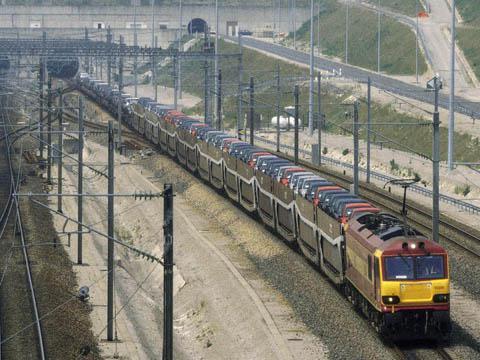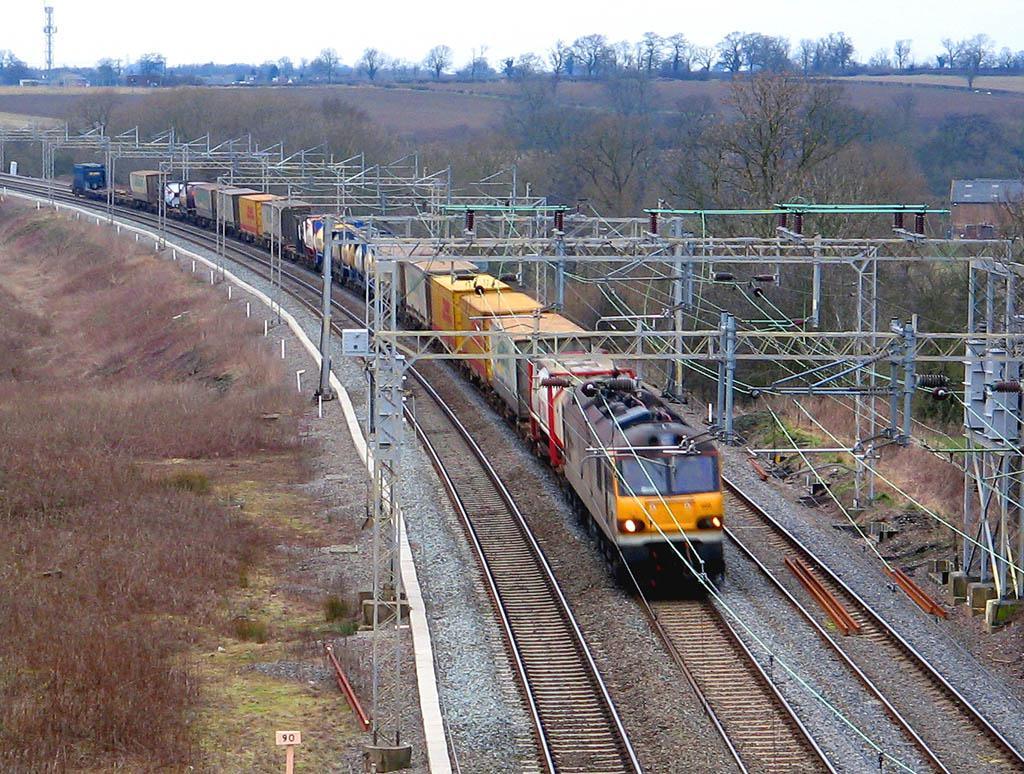The first image is the image on the left, the second image is the image on the right. Examine the images to the left and right. Is the description "Right image shows a green train moving in a rightward direction." accurate? Answer yes or no. No. The first image is the image on the left, the second image is the image on the right. Evaluate the accuracy of this statement regarding the images: "At least one of the trains in one of the images is passing through a grassy area.". Is it true? Answer yes or no. No. 